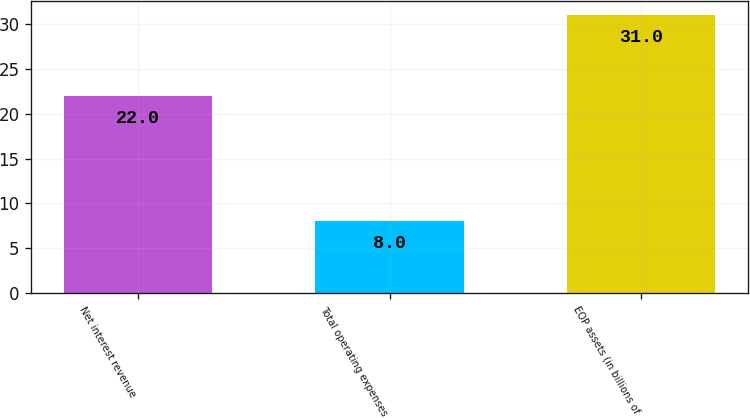<chart> <loc_0><loc_0><loc_500><loc_500><bar_chart><fcel>Net interest revenue<fcel>Total operating expenses<fcel>EOP assets (in billions of<nl><fcel>22<fcel>8<fcel>31<nl></chart> 